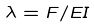Convert formula to latex. <formula><loc_0><loc_0><loc_500><loc_500>\lambda = F / E I</formula> 